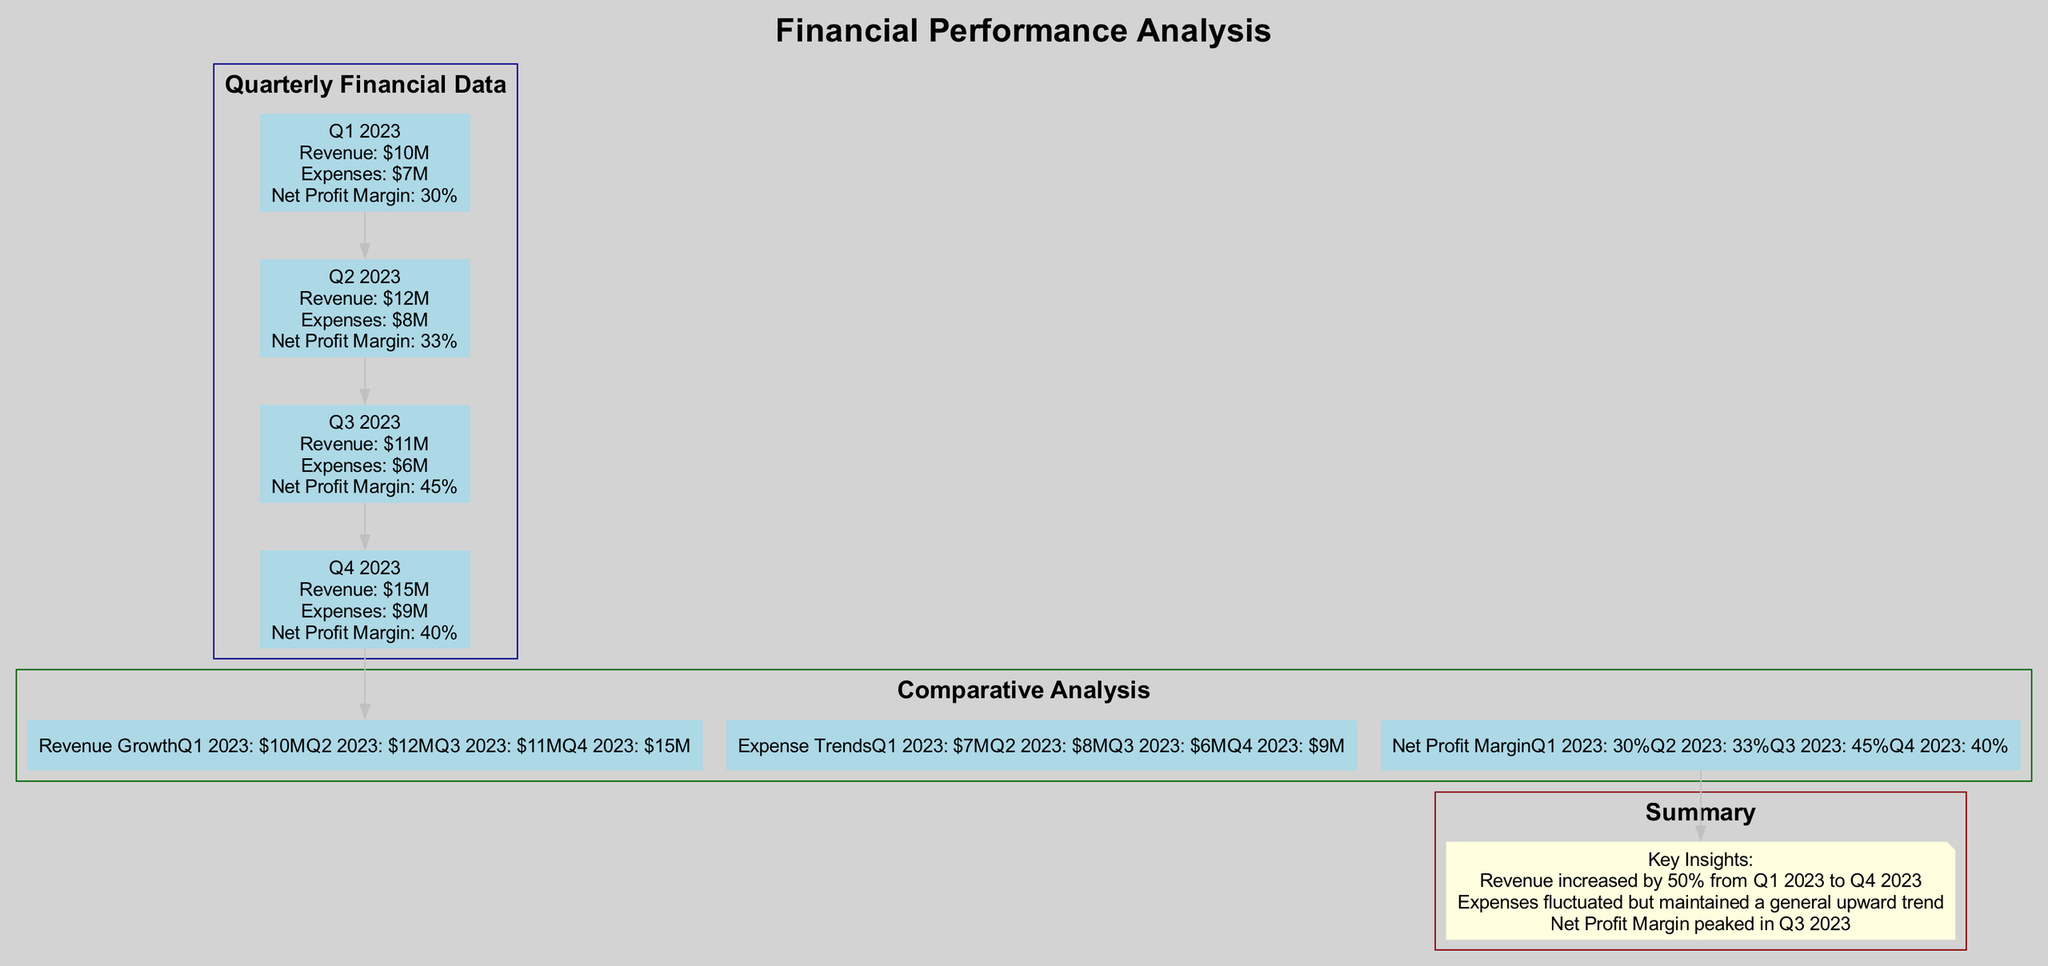What is the revenue for Q3 2023? The revenue for Q3 2023 can be found in the "Quarterly Financial Data" section. The corresponding node shows that the revenue for this quarter is "$11M".
Answer: $11M What is the highest net profit margin in the diagram? By examining the "Net Profit Margin" values under the "Comparative Analysis" section, Q3 2023 has the highest net profit margin at "45%".
Answer: 45% How much did expenses increase from Q1 2023 to Q4 2023? The expenses for Q1 2023 are "$7M", and for Q4 2023 they are "$9M". The increase is calculated as $9M - $7M, which equals "$2M".
Answer: $2M Which quarter had the lowest expenses? Looking at the "Expenses" values listed in the "Quarterly Financial Data", Q3 2023 shows the lowest expenses at "$6M".
Answer: Q3 2023 What was the revenue growth from Q1 2023 to Q4 2023? To find the revenue growth, we compare the revenue in Q1 2023 "$10M" and in Q4 2023 "$15M". The growth is $15M - $10M, which equals "$5M".
Answer: $5M How did the net profit margin change from Q2 2023 to Q3 2023? The net profit margin for Q2 2023 is "33%" and for Q3 2023 it is "45%". This indicates an increase when going from Q2 to Q3 of "12%".
Answer: 12% What are the key insights provided in the summary? The summary lists key insights. The insights state there was a 50% revenue increase from Q1 2023 to Q4 2023, expenses fluctuated generally upwards, and the net profit margin peaked in Q3 2023.
Answer: 50% revenue increase, fluctuating expenses, peaked net profit margin in Q3 2023 How many edges are there connecting the quarterly nodes? The "Quarterly Financial Data" segment shows four quarterly nodes (Q1 to Q4). Since each node connects to the next, there are three edges connecting them (Q1 to Q2, Q2 to Q3, and Q3 to Q4).
Answer: 3 Which quarter had the highest revenue? By reviewing the "Revenue" values, Q4 2023 has the highest revenue of "$15M".
Answer: Q4 2023 